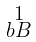<formula> <loc_0><loc_0><loc_500><loc_500>\begin{smallmatrix} 1 \\ b B \end{smallmatrix}</formula> 